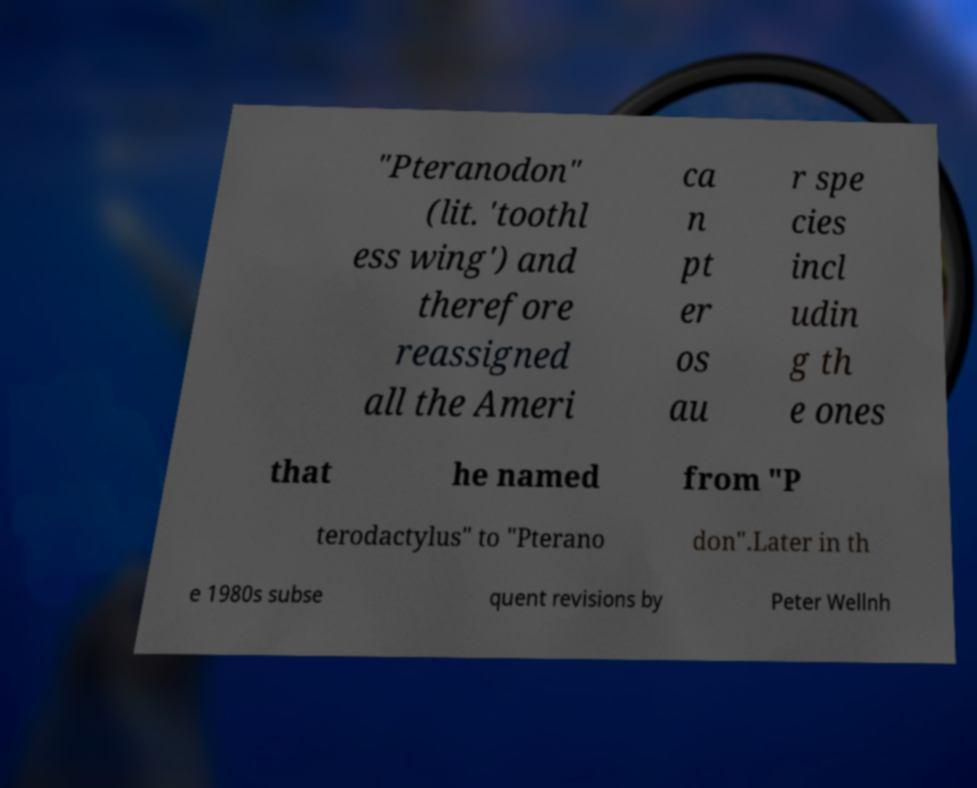For documentation purposes, I need the text within this image transcribed. Could you provide that? "Pteranodon" (lit. 'toothl ess wing') and therefore reassigned all the Ameri ca n pt er os au r spe cies incl udin g th e ones that he named from "P terodactylus" to "Pterano don".Later in th e 1980s subse quent revisions by Peter Wellnh 